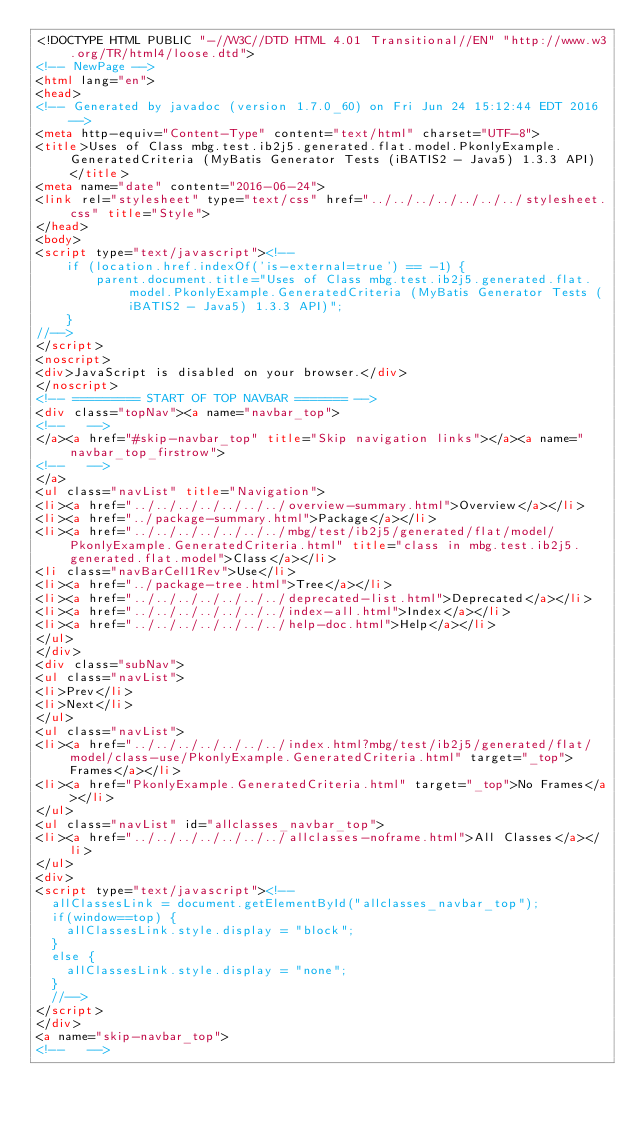Convert code to text. <code><loc_0><loc_0><loc_500><loc_500><_HTML_><!DOCTYPE HTML PUBLIC "-//W3C//DTD HTML 4.01 Transitional//EN" "http://www.w3.org/TR/html4/loose.dtd">
<!-- NewPage -->
<html lang="en">
<head>
<!-- Generated by javadoc (version 1.7.0_60) on Fri Jun 24 15:12:44 EDT 2016 -->
<meta http-equiv="Content-Type" content="text/html" charset="UTF-8">
<title>Uses of Class mbg.test.ib2j5.generated.flat.model.PkonlyExample.GeneratedCriteria (MyBatis Generator Tests (iBATIS2 - Java5) 1.3.3 API)</title>
<meta name="date" content="2016-06-24">
<link rel="stylesheet" type="text/css" href="../../../../../../../stylesheet.css" title="Style">
</head>
<body>
<script type="text/javascript"><!--
    if (location.href.indexOf('is-external=true') == -1) {
        parent.document.title="Uses of Class mbg.test.ib2j5.generated.flat.model.PkonlyExample.GeneratedCriteria (MyBatis Generator Tests (iBATIS2 - Java5) 1.3.3 API)";
    }
//-->
</script>
<noscript>
<div>JavaScript is disabled on your browser.</div>
</noscript>
<!-- ========= START OF TOP NAVBAR ======= -->
<div class="topNav"><a name="navbar_top">
<!--   -->
</a><a href="#skip-navbar_top" title="Skip navigation links"></a><a name="navbar_top_firstrow">
<!--   -->
</a>
<ul class="navList" title="Navigation">
<li><a href="../../../../../../../overview-summary.html">Overview</a></li>
<li><a href="../package-summary.html">Package</a></li>
<li><a href="../../../../../../../mbg/test/ib2j5/generated/flat/model/PkonlyExample.GeneratedCriteria.html" title="class in mbg.test.ib2j5.generated.flat.model">Class</a></li>
<li class="navBarCell1Rev">Use</li>
<li><a href="../package-tree.html">Tree</a></li>
<li><a href="../../../../../../../deprecated-list.html">Deprecated</a></li>
<li><a href="../../../../../../../index-all.html">Index</a></li>
<li><a href="../../../../../../../help-doc.html">Help</a></li>
</ul>
</div>
<div class="subNav">
<ul class="navList">
<li>Prev</li>
<li>Next</li>
</ul>
<ul class="navList">
<li><a href="../../../../../../../index.html?mbg/test/ib2j5/generated/flat/model/class-use/PkonlyExample.GeneratedCriteria.html" target="_top">Frames</a></li>
<li><a href="PkonlyExample.GeneratedCriteria.html" target="_top">No Frames</a></li>
</ul>
<ul class="navList" id="allclasses_navbar_top">
<li><a href="../../../../../../../allclasses-noframe.html">All Classes</a></li>
</ul>
<div>
<script type="text/javascript"><!--
  allClassesLink = document.getElementById("allclasses_navbar_top");
  if(window==top) {
    allClassesLink.style.display = "block";
  }
  else {
    allClassesLink.style.display = "none";
  }
  //-->
</script>
</div>
<a name="skip-navbar_top">
<!--   --></code> 